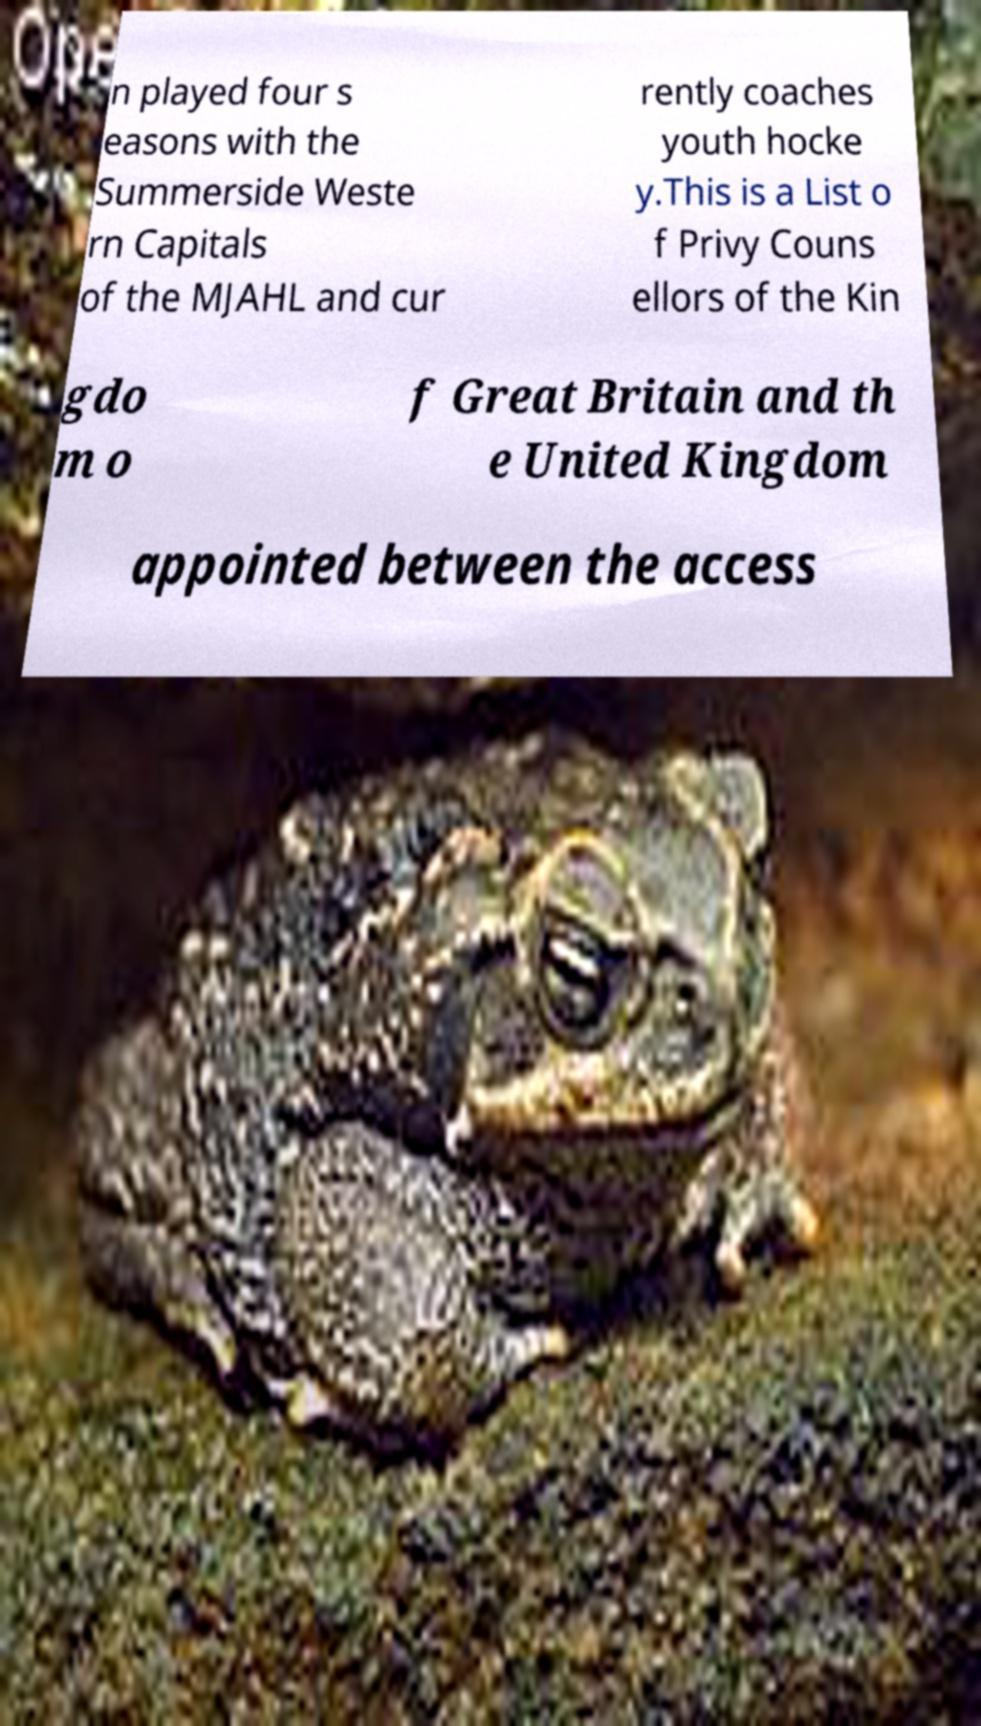There's text embedded in this image that I need extracted. Can you transcribe it verbatim? n played four s easons with the Summerside Weste rn Capitals of the MJAHL and cur rently coaches youth hocke y.This is a List o f Privy Couns ellors of the Kin gdo m o f Great Britain and th e United Kingdom appointed between the access 